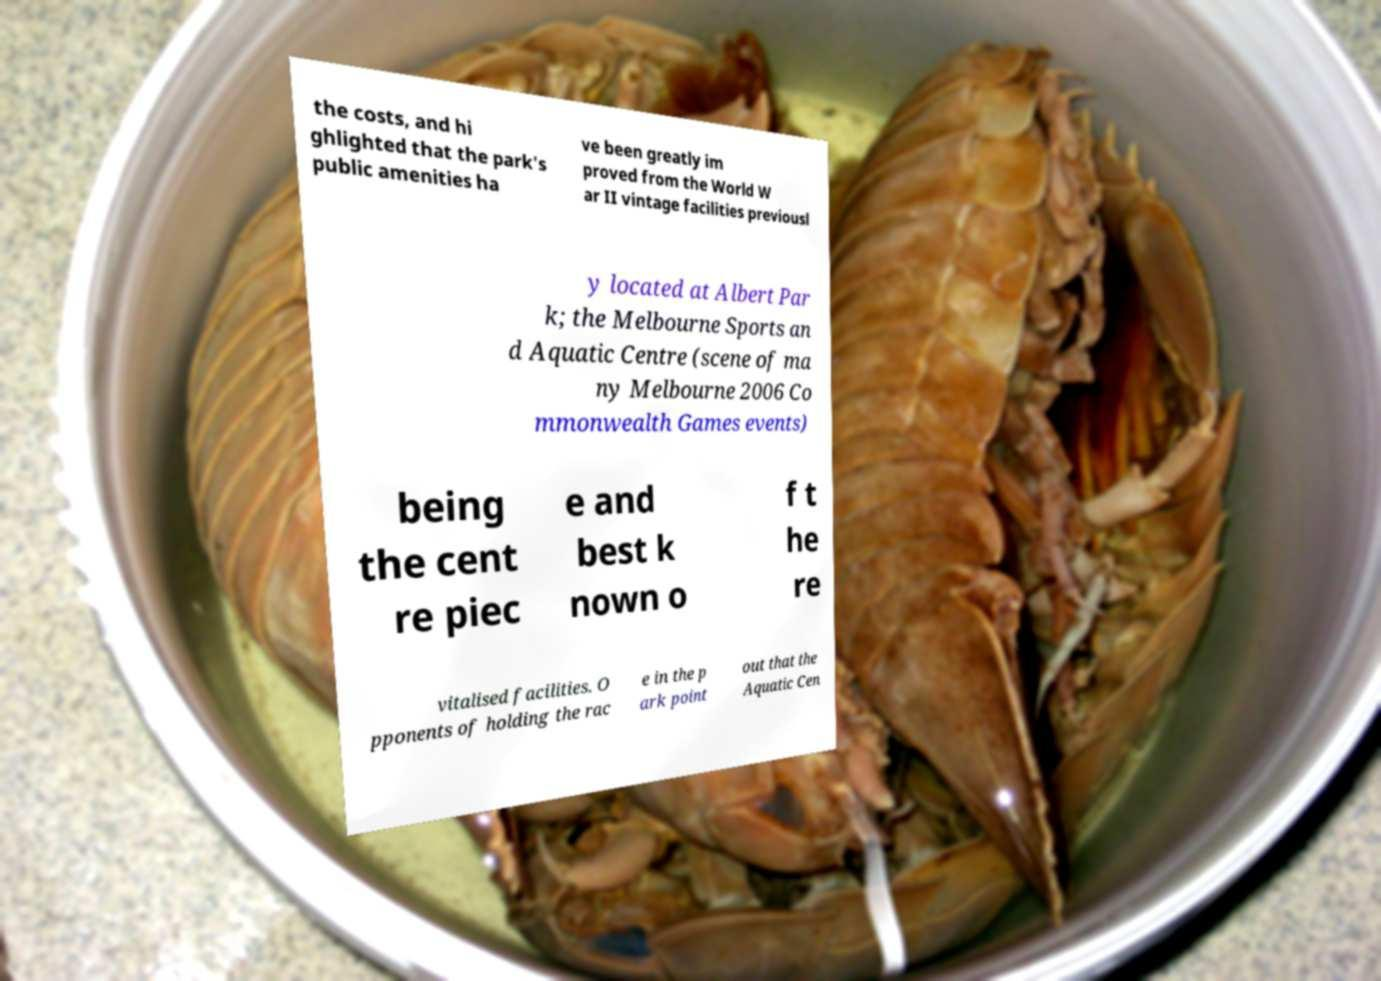Can you accurately transcribe the text from the provided image for me? the costs, and hi ghlighted that the park's public amenities ha ve been greatly im proved from the World W ar II vintage facilities previousl y located at Albert Par k; the Melbourne Sports an d Aquatic Centre (scene of ma ny Melbourne 2006 Co mmonwealth Games events) being the cent re piec e and best k nown o f t he re vitalised facilities. O pponents of holding the rac e in the p ark point out that the Aquatic Cen 